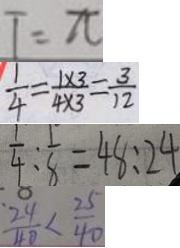Convert formula to latex. <formula><loc_0><loc_0><loc_500><loc_500>T = \pi 
 \frac { 1 } { 4 } = \frac { 1 \times 3 } { 4 \times 3 } = \frac { 3 } { 1 2 } 
 \frac { 1 } { 4 } : \frac { 1 } { 8 } = 4 8 : 2 4 
 \frac { 2 4 } { 4 0 } < \frac { 2 5 } { 4 0 }</formula> 